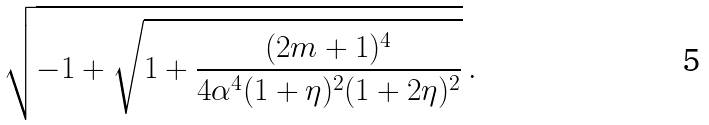<formula> <loc_0><loc_0><loc_500><loc_500>\sqrt { - 1 + \sqrt { 1 + \frac { ( 2 m + 1 ) ^ { 4 } } { 4 \alpha ^ { 4 } ( 1 + \eta ) ^ { 2 } ( 1 + 2 \eta ) ^ { 2 } } } } \, .</formula> 